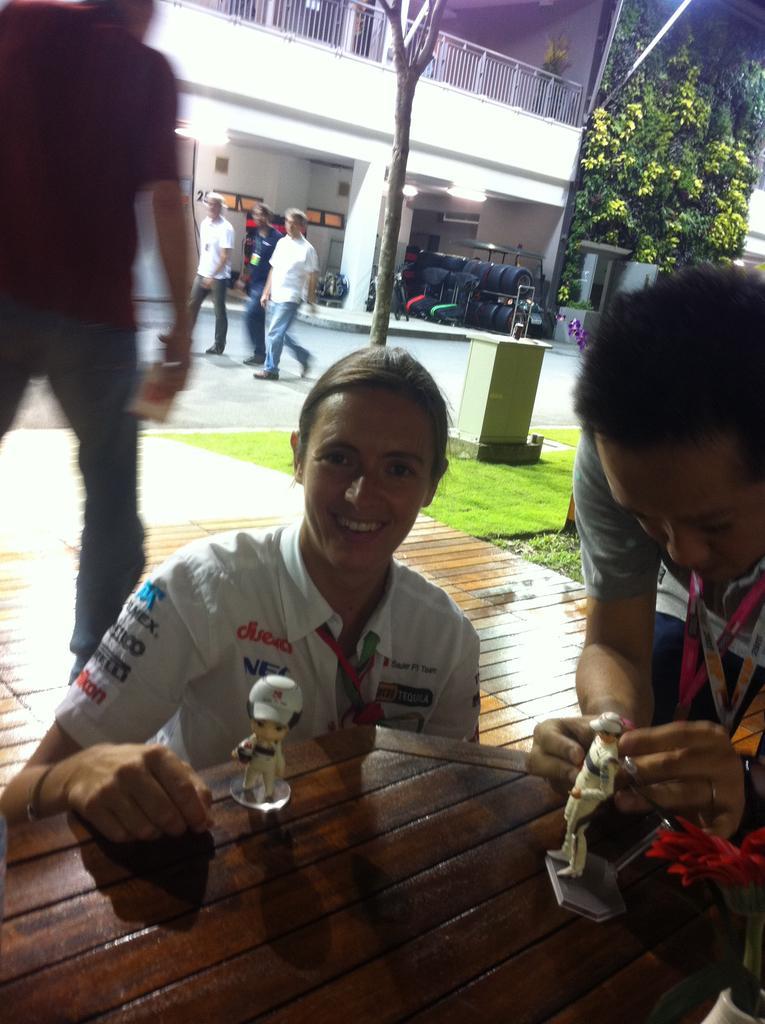Describe this image in one or two sentences. There are three people,in front of these two people we can see toys on the table. In the background we can see grass,trees,building,fence,tires and there are three people walking. 